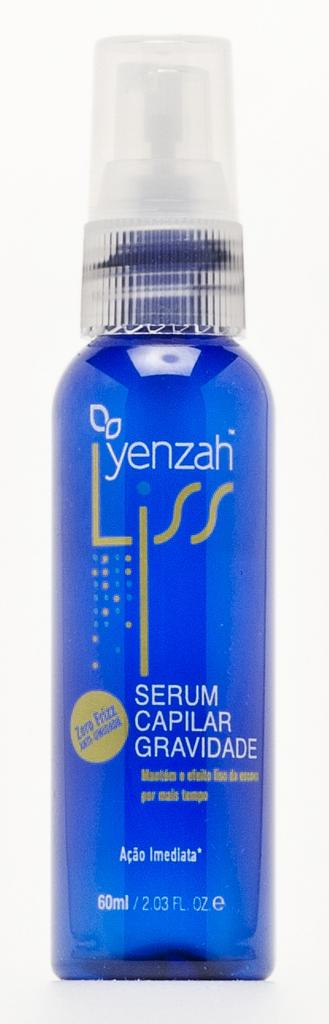How many ounces does this bottle have?
Provide a short and direct response. 2.03. 